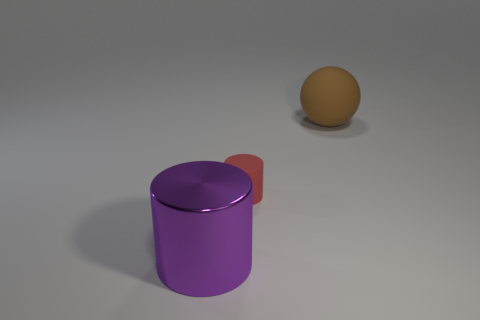Add 2 big purple metal objects. How many objects exist? 5 Subtract all balls. How many objects are left? 2 Add 2 large purple shiny cylinders. How many large purple shiny cylinders exist? 3 Subtract 1 brown balls. How many objects are left? 2 Subtract all red cylinders. Subtract all brown matte blocks. How many objects are left? 2 Add 3 small things. How many small things are left? 4 